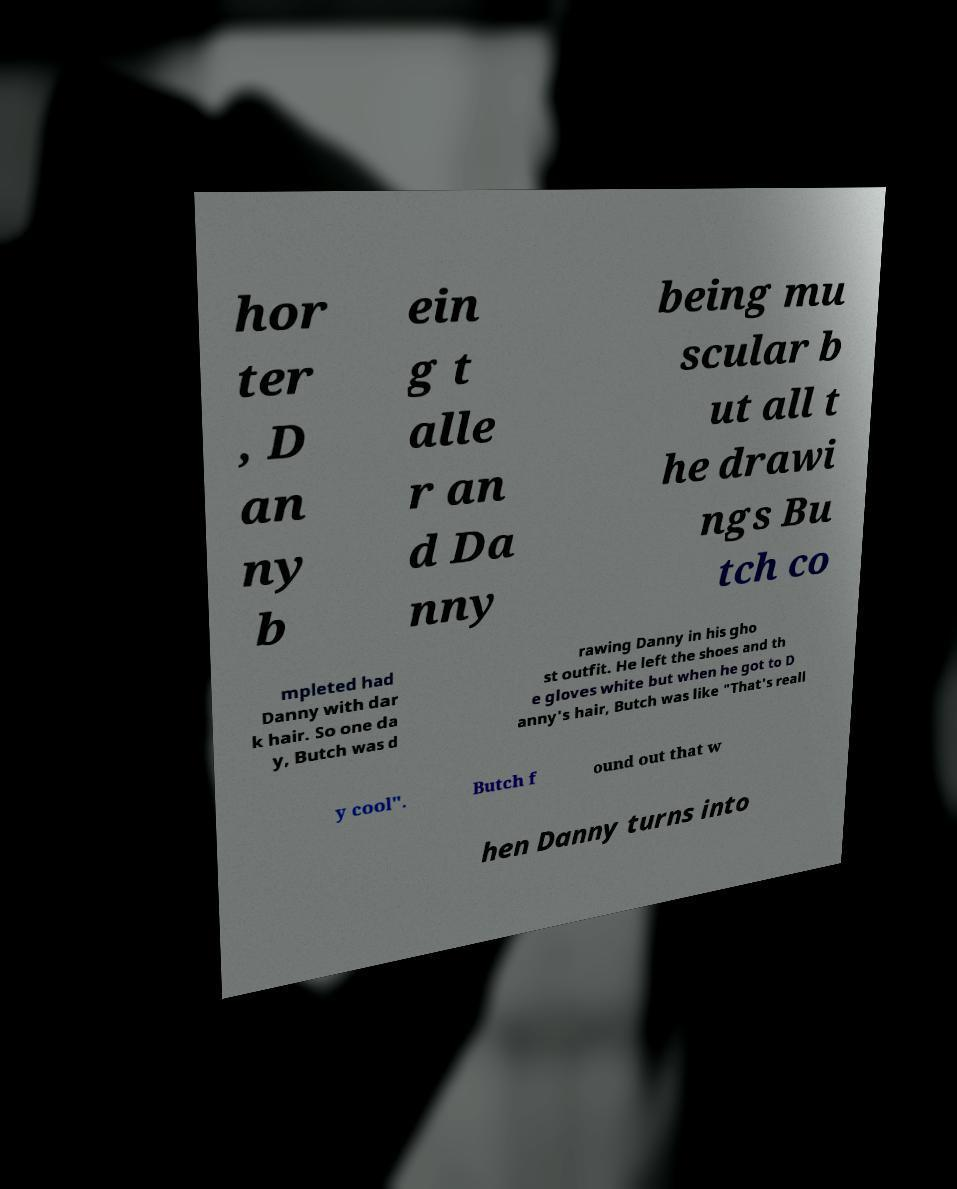Can you accurately transcribe the text from the provided image for me? hor ter , D an ny b ein g t alle r an d Da nny being mu scular b ut all t he drawi ngs Bu tch co mpleted had Danny with dar k hair. So one da y, Butch was d rawing Danny in his gho st outfit. He left the shoes and th e gloves white but when he got to D anny's hair, Butch was like "That's reall y cool". Butch f ound out that w hen Danny turns into 